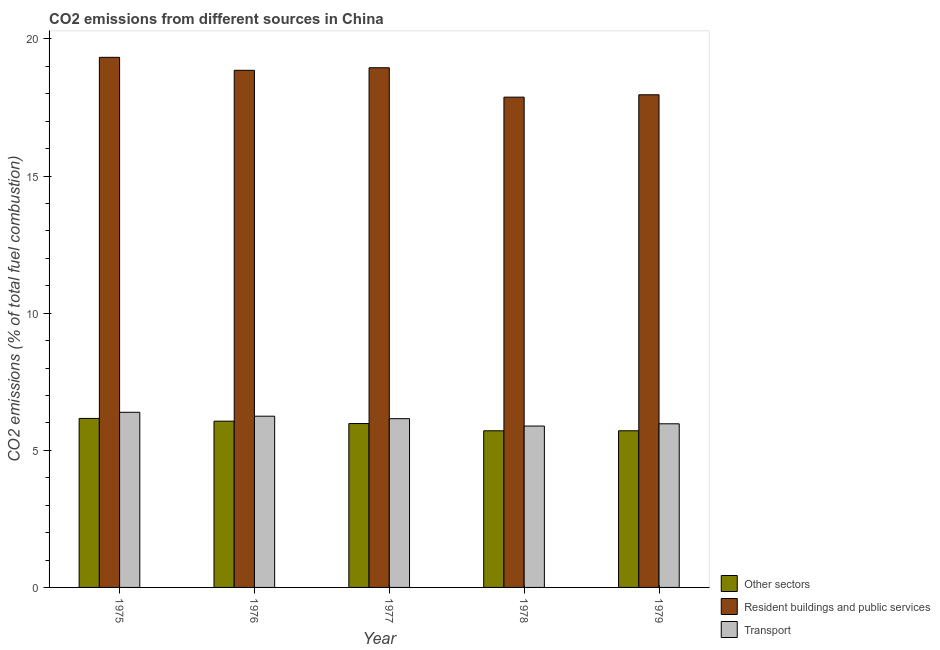How many different coloured bars are there?
Offer a terse response. 3. Are the number of bars per tick equal to the number of legend labels?
Give a very brief answer. Yes. Are the number of bars on each tick of the X-axis equal?
Your answer should be compact. Yes. What is the label of the 3rd group of bars from the left?
Provide a succinct answer. 1977. What is the percentage of co2 emissions from other sectors in 1976?
Provide a short and direct response. 6.06. Across all years, what is the maximum percentage of co2 emissions from other sectors?
Provide a succinct answer. 6.16. Across all years, what is the minimum percentage of co2 emissions from other sectors?
Offer a very short reply. 5.71. In which year was the percentage of co2 emissions from resident buildings and public services maximum?
Ensure brevity in your answer.  1975. In which year was the percentage of co2 emissions from resident buildings and public services minimum?
Ensure brevity in your answer.  1978. What is the total percentage of co2 emissions from resident buildings and public services in the graph?
Provide a succinct answer. 92.98. What is the difference between the percentage of co2 emissions from other sectors in 1976 and that in 1979?
Your answer should be very brief. 0.35. What is the difference between the percentage of co2 emissions from transport in 1979 and the percentage of co2 emissions from resident buildings and public services in 1976?
Offer a terse response. -0.28. What is the average percentage of co2 emissions from other sectors per year?
Offer a terse response. 5.93. What is the ratio of the percentage of co2 emissions from transport in 1976 to that in 1978?
Provide a succinct answer. 1.06. What is the difference between the highest and the second highest percentage of co2 emissions from resident buildings and public services?
Ensure brevity in your answer.  0.38. What is the difference between the highest and the lowest percentage of co2 emissions from other sectors?
Provide a short and direct response. 0.45. What does the 1st bar from the left in 1977 represents?
Offer a very short reply. Other sectors. What does the 1st bar from the right in 1979 represents?
Provide a short and direct response. Transport. Is it the case that in every year, the sum of the percentage of co2 emissions from other sectors and percentage of co2 emissions from resident buildings and public services is greater than the percentage of co2 emissions from transport?
Make the answer very short. Yes. Are all the bars in the graph horizontal?
Ensure brevity in your answer.  No. Are the values on the major ticks of Y-axis written in scientific E-notation?
Your answer should be compact. No. Does the graph contain any zero values?
Provide a succinct answer. No. Does the graph contain grids?
Provide a succinct answer. No. How are the legend labels stacked?
Your response must be concise. Vertical. What is the title of the graph?
Make the answer very short. CO2 emissions from different sources in China. What is the label or title of the X-axis?
Provide a short and direct response. Year. What is the label or title of the Y-axis?
Offer a very short reply. CO2 emissions (% of total fuel combustion). What is the CO2 emissions (% of total fuel combustion) of Other sectors in 1975?
Make the answer very short. 6.16. What is the CO2 emissions (% of total fuel combustion) of Resident buildings and public services in 1975?
Your answer should be compact. 19.33. What is the CO2 emissions (% of total fuel combustion) of Transport in 1975?
Give a very brief answer. 6.39. What is the CO2 emissions (% of total fuel combustion) of Other sectors in 1976?
Give a very brief answer. 6.06. What is the CO2 emissions (% of total fuel combustion) of Resident buildings and public services in 1976?
Your answer should be very brief. 18.86. What is the CO2 emissions (% of total fuel combustion) in Transport in 1976?
Your answer should be compact. 6.24. What is the CO2 emissions (% of total fuel combustion) in Other sectors in 1977?
Give a very brief answer. 5.98. What is the CO2 emissions (% of total fuel combustion) of Resident buildings and public services in 1977?
Provide a short and direct response. 18.95. What is the CO2 emissions (% of total fuel combustion) in Transport in 1977?
Your answer should be compact. 6.15. What is the CO2 emissions (% of total fuel combustion) in Other sectors in 1978?
Your response must be concise. 5.71. What is the CO2 emissions (% of total fuel combustion) in Resident buildings and public services in 1978?
Your answer should be very brief. 17.88. What is the CO2 emissions (% of total fuel combustion) in Transport in 1978?
Give a very brief answer. 5.89. What is the CO2 emissions (% of total fuel combustion) of Other sectors in 1979?
Offer a very short reply. 5.71. What is the CO2 emissions (% of total fuel combustion) in Resident buildings and public services in 1979?
Keep it short and to the point. 17.97. What is the CO2 emissions (% of total fuel combustion) of Transport in 1979?
Your answer should be very brief. 5.97. Across all years, what is the maximum CO2 emissions (% of total fuel combustion) in Other sectors?
Keep it short and to the point. 6.16. Across all years, what is the maximum CO2 emissions (% of total fuel combustion) of Resident buildings and public services?
Your answer should be compact. 19.33. Across all years, what is the maximum CO2 emissions (% of total fuel combustion) in Transport?
Give a very brief answer. 6.39. Across all years, what is the minimum CO2 emissions (% of total fuel combustion) of Other sectors?
Keep it short and to the point. 5.71. Across all years, what is the minimum CO2 emissions (% of total fuel combustion) of Resident buildings and public services?
Offer a very short reply. 17.88. Across all years, what is the minimum CO2 emissions (% of total fuel combustion) of Transport?
Provide a succinct answer. 5.89. What is the total CO2 emissions (% of total fuel combustion) in Other sectors in the graph?
Offer a very short reply. 29.63. What is the total CO2 emissions (% of total fuel combustion) in Resident buildings and public services in the graph?
Keep it short and to the point. 92.98. What is the total CO2 emissions (% of total fuel combustion) in Transport in the graph?
Offer a terse response. 30.64. What is the difference between the CO2 emissions (% of total fuel combustion) in Other sectors in 1975 and that in 1976?
Make the answer very short. 0.1. What is the difference between the CO2 emissions (% of total fuel combustion) in Resident buildings and public services in 1975 and that in 1976?
Make the answer very short. 0.47. What is the difference between the CO2 emissions (% of total fuel combustion) of Transport in 1975 and that in 1976?
Provide a succinct answer. 0.14. What is the difference between the CO2 emissions (% of total fuel combustion) of Other sectors in 1975 and that in 1977?
Your response must be concise. 0.19. What is the difference between the CO2 emissions (% of total fuel combustion) of Resident buildings and public services in 1975 and that in 1977?
Make the answer very short. 0.38. What is the difference between the CO2 emissions (% of total fuel combustion) of Transport in 1975 and that in 1977?
Offer a terse response. 0.23. What is the difference between the CO2 emissions (% of total fuel combustion) in Other sectors in 1975 and that in 1978?
Make the answer very short. 0.45. What is the difference between the CO2 emissions (% of total fuel combustion) in Resident buildings and public services in 1975 and that in 1978?
Make the answer very short. 1.45. What is the difference between the CO2 emissions (% of total fuel combustion) of Transport in 1975 and that in 1978?
Provide a succinct answer. 0.5. What is the difference between the CO2 emissions (% of total fuel combustion) in Other sectors in 1975 and that in 1979?
Provide a short and direct response. 0.45. What is the difference between the CO2 emissions (% of total fuel combustion) in Resident buildings and public services in 1975 and that in 1979?
Keep it short and to the point. 1.37. What is the difference between the CO2 emissions (% of total fuel combustion) in Transport in 1975 and that in 1979?
Make the answer very short. 0.42. What is the difference between the CO2 emissions (% of total fuel combustion) of Other sectors in 1976 and that in 1977?
Your answer should be compact. 0.09. What is the difference between the CO2 emissions (% of total fuel combustion) in Resident buildings and public services in 1976 and that in 1977?
Keep it short and to the point. -0.09. What is the difference between the CO2 emissions (% of total fuel combustion) in Transport in 1976 and that in 1977?
Provide a succinct answer. 0.09. What is the difference between the CO2 emissions (% of total fuel combustion) of Other sectors in 1976 and that in 1978?
Your answer should be compact. 0.35. What is the difference between the CO2 emissions (% of total fuel combustion) in Resident buildings and public services in 1976 and that in 1978?
Provide a short and direct response. 0.98. What is the difference between the CO2 emissions (% of total fuel combustion) of Transport in 1976 and that in 1978?
Make the answer very short. 0.36. What is the difference between the CO2 emissions (% of total fuel combustion) of Other sectors in 1976 and that in 1979?
Your answer should be compact. 0.35. What is the difference between the CO2 emissions (% of total fuel combustion) of Resident buildings and public services in 1976 and that in 1979?
Provide a short and direct response. 0.89. What is the difference between the CO2 emissions (% of total fuel combustion) in Transport in 1976 and that in 1979?
Ensure brevity in your answer.  0.28. What is the difference between the CO2 emissions (% of total fuel combustion) of Other sectors in 1977 and that in 1978?
Ensure brevity in your answer.  0.26. What is the difference between the CO2 emissions (% of total fuel combustion) of Resident buildings and public services in 1977 and that in 1978?
Give a very brief answer. 1.07. What is the difference between the CO2 emissions (% of total fuel combustion) in Transport in 1977 and that in 1978?
Offer a very short reply. 0.27. What is the difference between the CO2 emissions (% of total fuel combustion) in Other sectors in 1977 and that in 1979?
Your answer should be very brief. 0.26. What is the difference between the CO2 emissions (% of total fuel combustion) of Resident buildings and public services in 1977 and that in 1979?
Keep it short and to the point. 0.98. What is the difference between the CO2 emissions (% of total fuel combustion) in Transport in 1977 and that in 1979?
Your answer should be compact. 0.19. What is the difference between the CO2 emissions (% of total fuel combustion) in Other sectors in 1978 and that in 1979?
Provide a short and direct response. -0. What is the difference between the CO2 emissions (% of total fuel combustion) of Resident buildings and public services in 1978 and that in 1979?
Provide a short and direct response. -0.09. What is the difference between the CO2 emissions (% of total fuel combustion) of Transport in 1978 and that in 1979?
Your answer should be very brief. -0.08. What is the difference between the CO2 emissions (% of total fuel combustion) of Other sectors in 1975 and the CO2 emissions (% of total fuel combustion) of Resident buildings and public services in 1976?
Your answer should be very brief. -12.69. What is the difference between the CO2 emissions (% of total fuel combustion) of Other sectors in 1975 and the CO2 emissions (% of total fuel combustion) of Transport in 1976?
Your response must be concise. -0.08. What is the difference between the CO2 emissions (% of total fuel combustion) of Resident buildings and public services in 1975 and the CO2 emissions (% of total fuel combustion) of Transport in 1976?
Your answer should be very brief. 13.09. What is the difference between the CO2 emissions (% of total fuel combustion) in Other sectors in 1975 and the CO2 emissions (% of total fuel combustion) in Resident buildings and public services in 1977?
Provide a succinct answer. -12.79. What is the difference between the CO2 emissions (% of total fuel combustion) of Other sectors in 1975 and the CO2 emissions (% of total fuel combustion) of Transport in 1977?
Keep it short and to the point. 0.01. What is the difference between the CO2 emissions (% of total fuel combustion) of Resident buildings and public services in 1975 and the CO2 emissions (% of total fuel combustion) of Transport in 1977?
Ensure brevity in your answer.  13.18. What is the difference between the CO2 emissions (% of total fuel combustion) in Other sectors in 1975 and the CO2 emissions (% of total fuel combustion) in Resident buildings and public services in 1978?
Your answer should be very brief. -11.72. What is the difference between the CO2 emissions (% of total fuel combustion) in Other sectors in 1975 and the CO2 emissions (% of total fuel combustion) in Transport in 1978?
Offer a terse response. 0.28. What is the difference between the CO2 emissions (% of total fuel combustion) in Resident buildings and public services in 1975 and the CO2 emissions (% of total fuel combustion) in Transport in 1978?
Your answer should be very brief. 13.45. What is the difference between the CO2 emissions (% of total fuel combustion) in Other sectors in 1975 and the CO2 emissions (% of total fuel combustion) in Resident buildings and public services in 1979?
Offer a very short reply. -11.8. What is the difference between the CO2 emissions (% of total fuel combustion) of Other sectors in 1975 and the CO2 emissions (% of total fuel combustion) of Transport in 1979?
Offer a very short reply. 0.2. What is the difference between the CO2 emissions (% of total fuel combustion) in Resident buildings and public services in 1975 and the CO2 emissions (% of total fuel combustion) in Transport in 1979?
Your answer should be compact. 13.36. What is the difference between the CO2 emissions (% of total fuel combustion) in Other sectors in 1976 and the CO2 emissions (% of total fuel combustion) in Resident buildings and public services in 1977?
Offer a very short reply. -12.89. What is the difference between the CO2 emissions (% of total fuel combustion) in Other sectors in 1976 and the CO2 emissions (% of total fuel combustion) in Transport in 1977?
Offer a very short reply. -0.09. What is the difference between the CO2 emissions (% of total fuel combustion) of Resident buildings and public services in 1976 and the CO2 emissions (% of total fuel combustion) of Transport in 1977?
Your answer should be compact. 12.7. What is the difference between the CO2 emissions (% of total fuel combustion) of Other sectors in 1976 and the CO2 emissions (% of total fuel combustion) of Resident buildings and public services in 1978?
Give a very brief answer. -11.82. What is the difference between the CO2 emissions (% of total fuel combustion) in Other sectors in 1976 and the CO2 emissions (% of total fuel combustion) in Transport in 1978?
Give a very brief answer. 0.18. What is the difference between the CO2 emissions (% of total fuel combustion) in Resident buildings and public services in 1976 and the CO2 emissions (% of total fuel combustion) in Transport in 1978?
Offer a very short reply. 12.97. What is the difference between the CO2 emissions (% of total fuel combustion) of Other sectors in 1976 and the CO2 emissions (% of total fuel combustion) of Resident buildings and public services in 1979?
Give a very brief answer. -11.9. What is the difference between the CO2 emissions (% of total fuel combustion) of Other sectors in 1976 and the CO2 emissions (% of total fuel combustion) of Transport in 1979?
Give a very brief answer. 0.1. What is the difference between the CO2 emissions (% of total fuel combustion) of Resident buildings and public services in 1976 and the CO2 emissions (% of total fuel combustion) of Transport in 1979?
Your answer should be very brief. 12.89. What is the difference between the CO2 emissions (% of total fuel combustion) in Other sectors in 1977 and the CO2 emissions (% of total fuel combustion) in Resident buildings and public services in 1978?
Give a very brief answer. -11.9. What is the difference between the CO2 emissions (% of total fuel combustion) of Other sectors in 1977 and the CO2 emissions (% of total fuel combustion) of Transport in 1978?
Ensure brevity in your answer.  0.09. What is the difference between the CO2 emissions (% of total fuel combustion) in Resident buildings and public services in 1977 and the CO2 emissions (% of total fuel combustion) in Transport in 1978?
Provide a succinct answer. 13.07. What is the difference between the CO2 emissions (% of total fuel combustion) of Other sectors in 1977 and the CO2 emissions (% of total fuel combustion) of Resident buildings and public services in 1979?
Offer a terse response. -11.99. What is the difference between the CO2 emissions (% of total fuel combustion) of Other sectors in 1977 and the CO2 emissions (% of total fuel combustion) of Transport in 1979?
Your answer should be very brief. 0.01. What is the difference between the CO2 emissions (% of total fuel combustion) of Resident buildings and public services in 1977 and the CO2 emissions (% of total fuel combustion) of Transport in 1979?
Provide a succinct answer. 12.98. What is the difference between the CO2 emissions (% of total fuel combustion) in Other sectors in 1978 and the CO2 emissions (% of total fuel combustion) in Resident buildings and public services in 1979?
Make the answer very short. -12.25. What is the difference between the CO2 emissions (% of total fuel combustion) in Other sectors in 1978 and the CO2 emissions (% of total fuel combustion) in Transport in 1979?
Ensure brevity in your answer.  -0.26. What is the difference between the CO2 emissions (% of total fuel combustion) of Resident buildings and public services in 1978 and the CO2 emissions (% of total fuel combustion) of Transport in 1979?
Keep it short and to the point. 11.91. What is the average CO2 emissions (% of total fuel combustion) of Other sectors per year?
Your response must be concise. 5.93. What is the average CO2 emissions (% of total fuel combustion) of Resident buildings and public services per year?
Ensure brevity in your answer.  18.6. What is the average CO2 emissions (% of total fuel combustion) of Transport per year?
Provide a succinct answer. 6.13. In the year 1975, what is the difference between the CO2 emissions (% of total fuel combustion) in Other sectors and CO2 emissions (% of total fuel combustion) in Resident buildings and public services?
Offer a terse response. -13.17. In the year 1975, what is the difference between the CO2 emissions (% of total fuel combustion) of Other sectors and CO2 emissions (% of total fuel combustion) of Transport?
Give a very brief answer. -0.22. In the year 1975, what is the difference between the CO2 emissions (% of total fuel combustion) of Resident buildings and public services and CO2 emissions (% of total fuel combustion) of Transport?
Your response must be concise. 12.94. In the year 1976, what is the difference between the CO2 emissions (% of total fuel combustion) in Other sectors and CO2 emissions (% of total fuel combustion) in Resident buildings and public services?
Make the answer very short. -12.79. In the year 1976, what is the difference between the CO2 emissions (% of total fuel combustion) of Other sectors and CO2 emissions (% of total fuel combustion) of Transport?
Provide a short and direct response. -0.18. In the year 1976, what is the difference between the CO2 emissions (% of total fuel combustion) in Resident buildings and public services and CO2 emissions (% of total fuel combustion) in Transport?
Your response must be concise. 12.61. In the year 1977, what is the difference between the CO2 emissions (% of total fuel combustion) in Other sectors and CO2 emissions (% of total fuel combustion) in Resident buildings and public services?
Give a very brief answer. -12.97. In the year 1977, what is the difference between the CO2 emissions (% of total fuel combustion) in Other sectors and CO2 emissions (% of total fuel combustion) in Transport?
Offer a terse response. -0.18. In the year 1977, what is the difference between the CO2 emissions (% of total fuel combustion) in Resident buildings and public services and CO2 emissions (% of total fuel combustion) in Transport?
Provide a succinct answer. 12.8. In the year 1978, what is the difference between the CO2 emissions (% of total fuel combustion) in Other sectors and CO2 emissions (% of total fuel combustion) in Resident buildings and public services?
Your answer should be compact. -12.17. In the year 1978, what is the difference between the CO2 emissions (% of total fuel combustion) in Other sectors and CO2 emissions (% of total fuel combustion) in Transport?
Ensure brevity in your answer.  -0.17. In the year 1978, what is the difference between the CO2 emissions (% of total fuel combustion) of Resident buildings and public services and CO2 emissions (% of total fuel combustion) of Transport?
Your response must be concise. 11.99. In the year 1979, what is the difference between the CO2 emissions (% of total fuel combustion) of Other sectors and CO2 emissions (% of total fuel combustion) of Resident buildings and public services?
Your answer should be compact. -12.25. In the year 1979, what is the difference between the CO2 emissions (% of total fuel combustion) in Other sectors and CO2 emissions (% of total fuel combustion) in Transport?
Your response must be concise. -0.26. In the year 1979, what is the difference between the CO2 emissions (% of total fuel combustion) of Resident buildings and public services and CO2 emissions (% of total fuel combustion) of Transport?
Keep it short and to the point. 12. What is the ratio of the CO2 emissions (% of total fuel combustion) in Other sectors in 1975 to that in 1976?
Your answer should be compact. 1.02. What is the ratio of the CO2 emissions (% of total fuel combustion) of Resident buildings and public services in 1975 to that in 1976?
Your response must be concise. 1.03. What is the ratio of the CO2 emissions (% of total fuel combustion) in Transport in 1975 to that in 1976?
Give a very brief answer. 1.02. What is the ratio of the CO2 emissions (% of total fuel combustion) in Other sectors in 1975 to that in 1977?
Your response must be concise. 1.03. What is the ratio of the CO2 emissions (% of total fuel combustion) in Resident buildings and public services in 1975 to that in 1977?
Ensure brevity in your answer.  1.02. What is the ratio of the CO2 emissions (% of total fuel combustion) of Transport in 1975 to that in 1977?
Offer a terse response. 1.04. What is the ratio of the CO2 emissions (% of total fuel combustion) of Other sectors in 1975 to that in 1978?
Your answer should be compact. 1.08. What is the ratio of the CO2 emissions (% of total fuel combustion) in Resident buildings and public services in 1975 to that in 1978?
Your response must be concise. 1.08. What is the ratio of the CO2 emissions (% of total fuel combustion) in Transport in 1975 to that in 1978?
Your answer should be very brief. 1.09. What is the ratio of the CO2 emissions (% of total fuel combustion) of Other sectors in 1975 to that in 1979?
Your answer should be very brief. 1.08. What is the ratio of the CO2 emissions (% of total fuel combustion) of Resident buildings and public services in 1975 to that in 1979?
Ensure brevity in your answer.  1.08. What is the ratio of the CO2 emissions (% of total fuel combustion) of Transport in 1975 to that in 1979?
Keep it short and to the point. 1.07. What is the ratio of the CO2 emissions (% of total fuel combustion) in Other sectors in 1976 to that in 1977?
Your answer should be very brief. 1.01. What is the ratio of the CO2 emissions (% of total fuel combustion) of Transport in 1976 to that in 1977?
Provide a succinct answer. 1.01. What is the ratio of the CO2 emissions (% of total fuel combustion) of Other sectors in 1976 to that in 1978?
Your answer should be compact. 1.06. What is the ratio of the CO2 emissions (% of total fuel combustion) of Resident buildings and public services in 1976 to that in 1978?
Provide a succinct answer. 1.05. What is the ratio of the CO2 emissions (% of total fuel combustion) in Transport in 1976 to that in 1978?
Your answer should be compact. 1.06. What is the ratio of the CO2 emissions (% of total fuel combustion) in Other sectors in 1976 to that in 1979?
Offer a terse response. 1.06. What is the ratio of the CO2 emissions (% of total fuel combustion) of Resident buildings and public services in 1976 to that in 1979?
Offer a very short reply. 1.05. What is the ratio of the CO2 emissions (% of total fuel combustion) of Transport in 1976 to that in 1979?
Your response must be concise. 1.05. What is the ratio of the CO2 emissions (% of total fuel combustion) in Other sectors in 1977 to that in 1978?
Provide a succinct answer. 1.05. What is the ratio of the CO2 emissions (% of total fuel combustion) in Resident buildings and public services in 1977 to that in 1978?
Provide a succinct answer. 1.06. What is the ratio of the CO2 emissions (% of total fuel combustion) in Transport in 1977 to that in 1978?
Offer a terse response. 1.05. What is the ratio of the CO2 emissions (% of total fuel combustion) of Other sectors in 1977 to that in 1979?
Provide a short and direct response. 1.05. What is the ratio of the CO2 emissions (% of total fuel combustion) in Resident buildings and public services in 1977 to that in 1979?
Your answer should be very brief. 1.05. What is the ratio of the CO2 emissions (% of total fuel combustion) of Transport in 1977 to that in 1979?
Provide a short and direct response. 1.03. What is the ratio of the CO2 emissions (% of total fuel combustion) of Other sectors in 1978 to that in 1979?
Make the answer very short. 1. What is the ratio of the CO2 emissions (% of total fuel combustion) of Transport in 1978 to that in 1979?
Your answer should be very brief. 0.99. What is the difference between the highest and the second highest CO2 emissions (% of total fuel combustion) in Other sectors?
Give a very brief answer. 0.1. What is the difference between the highest and the second highest CO2 emissions (% of total fuel combustion) of Resident buildings and public services?
Provide a short and direct response. 0.38. What is the difference between the highest and the second highest CO2 emissions (% of total fuel combustion) of Transport?
Your answer should be compact. 0.14. What is the difference between the highest and the lowest CO2 emissions (% of total fuel combustion) of Other sectors?
Your response must be concise. 0.45. What is the difference between the highest and the lowest CO2 emissions (% of total fuel combustion) in Resident buildings and public services?
Offer a terse response. 1.45. What is the difference between the highest and the lowest CO2 emissions (% of total fuel combustion) of Transport?
Ensure brevity in your answer.  0.5. 